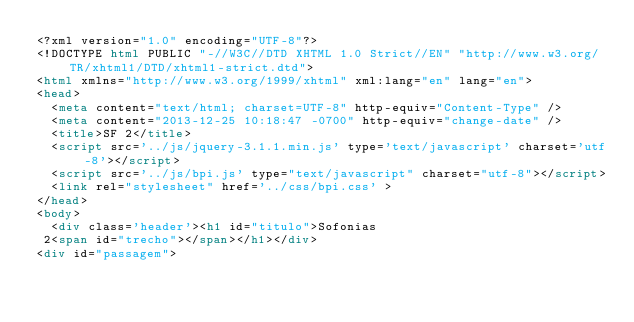Convert code to text. <code><loc_0><loc_0><loc_500><loc_500><_HTML_><?xml version="1.0" encoding="UTF-8"?>
<!DOCTYPE html PUBLIC "-//W3C//DTD XHTML 1.0 Strict//EN" "http://www.w3.org/TR/xhtml1/DTD/xhtml1-strict.dtd">
<html xmlns="http://www.w3.org/1999/xhtml" xml:lang="en" lang="en">
<head>
	<meta content="text/html; charset=UTF-8" http-equiv="Content-Type" />
	<meta content="2013-12-25 10:18:47 -0700" http-equiv="change-date" />
	<title>SF 2</title>
	<script src='../js/jquery-3.1.1.min.js' type='text/javascript' charset='utf-8'></script>
	<script src='../js/bpi.js' type="text/javascript" charset="utf-8"></script>
	<link rel="stylesheet" href='../css/bpi.css' >
</head>
<body>
	<div class='header'><h1 id="titulo">Sofonias
 2<span id="trecho"></span></h1></div>
<div id="passagem"></code> 